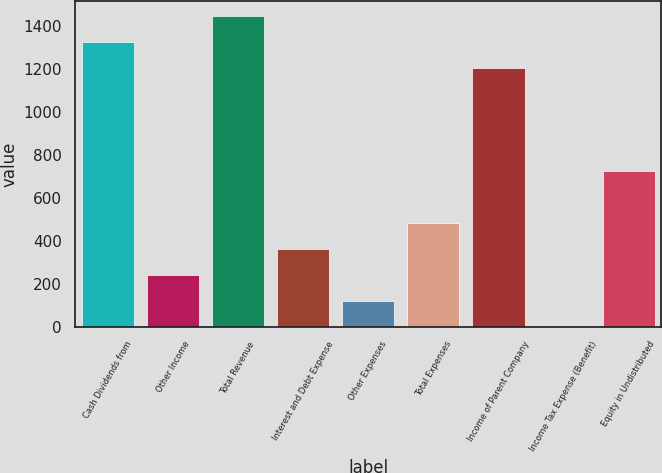Convert chart to OTSL. <chart><loc_0><loc_0><loc_500><loc_500><bar_chart><fcel>Cash Dividends from<fcel>Other Income<fcel>Total Revenue<fcel>Interest and Debt Expense<fcel>Other Expenses<fcel>Total Expenses<fcel>Income of Parent Company<fcel>Income Tax Expense (Benefit)<fcel>Equity in Undistributed<nl><fcel>1322.03<fcel>241.76<fcel>1442.06<fcel>361.79<fcel>121.73<fcel>481.82<fcel>1202<fcel>1.7<fcel>721.88<nl></chart> 